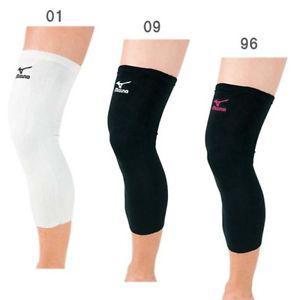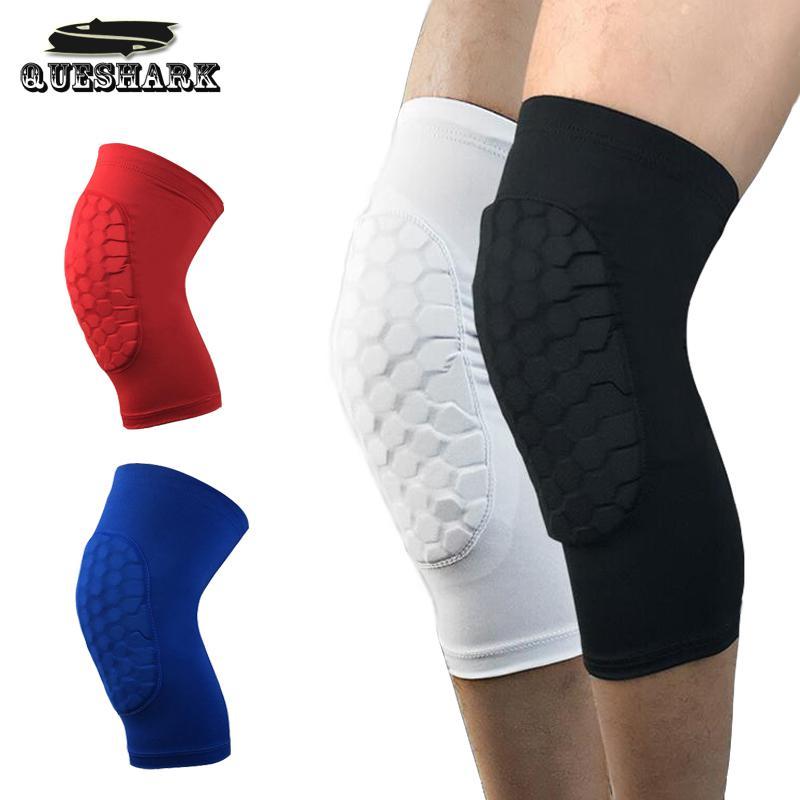The first image is the image on the left, the second image is the image on the right. Evaluate the accuracy of this statement regarding the images: "The left image is one black brace, the right image is one white brace.". Is it true? Answer yes or no. No. The first image is the image on the left, the second image is the image on the right. Given the left and right images, does the statement "An image shows a pair of legs with one one leg wearing a knee wrap." hold true? Answer yes or no. No. 